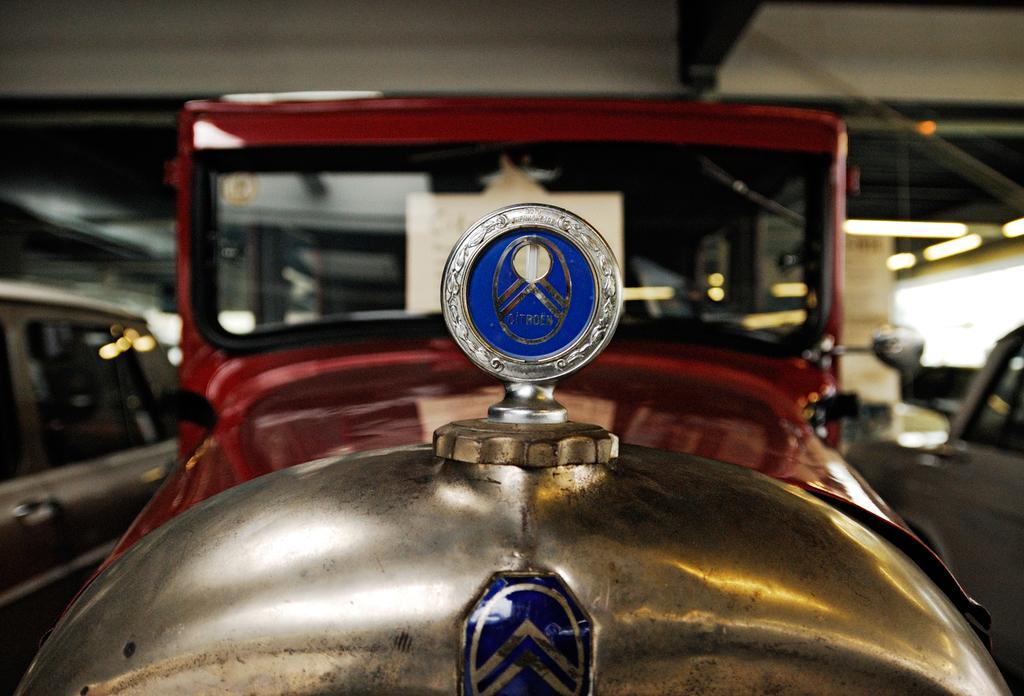How would you summarize this image in a sentence or two? In this image I can see few vehicles, in front the vehicle is in red and gold color and I can also see a blue color logo. 